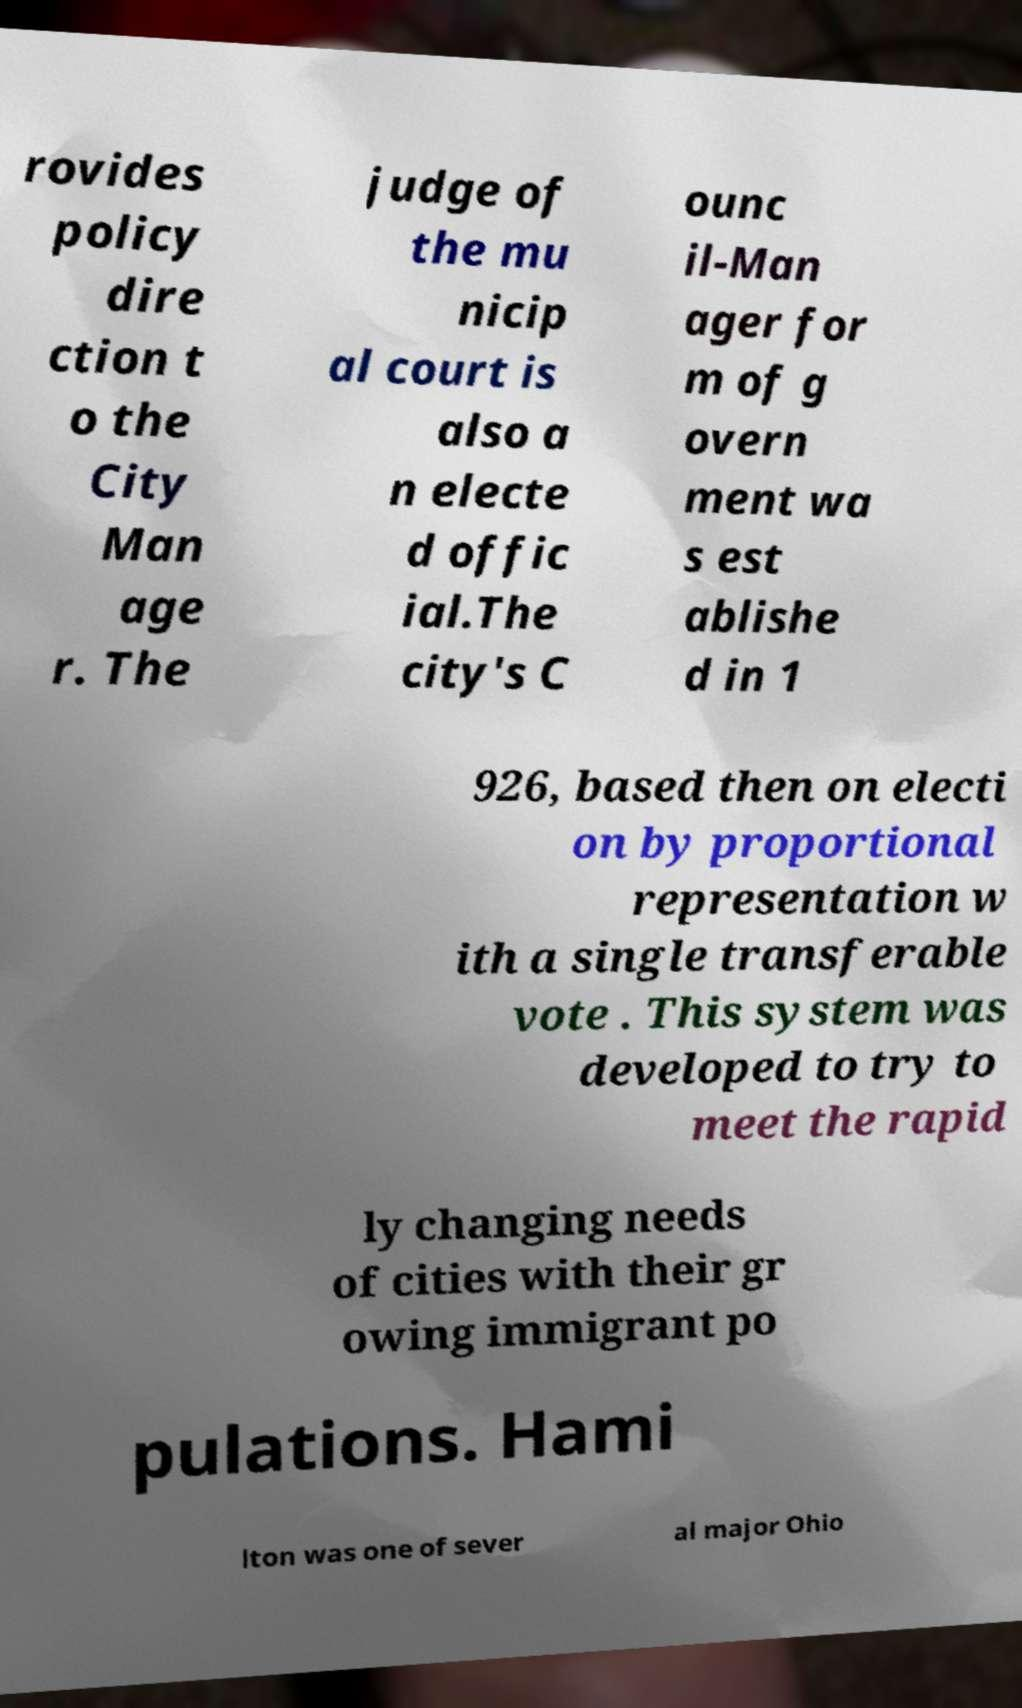Can you read and provide the text displayed in the image?This photo seems to have some interesting text. Can you extract and type it out for me? rovides policy dire ction t o the City Man age r. The judge of the mu nicip al court is also a n electe d offic ial.The city's C ounc il-Man ager for m of g overn ment wa s est ablishe d in 1 926, based then on electi on by proportional representation w ith a single transferable vote . This system was developed to try to meet the rapid ly changing needs of cities with their gr owing immigrant po pulations. Hami lton was one of sever al major Ohio 